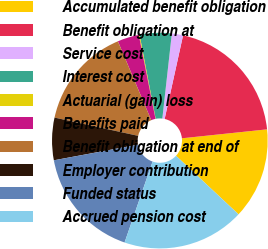Convert chart to OTSL. <chart><loc_0><loc_0><loc_500><loc_500><pie_chart><fcel>Accumulated benefit obligation<fcel>Benefit obligation at<fcel>Service cost<fcel>Interest cost<fcel>Actuarial (gain) loss<fcel>Benefits paid<fcel>Benefit obligation at end of<fcel>Employer contribution<fcel>Funded status<fcel>Accrued pension cost<nl><fcel>13.65%<fcel>19.88%<fcel>1.68%<fcel>4.79%<fcel>0.12%<fcel>3.23%<fcel>15.21%<fcel>6.35%<fcel>16.77%<fcel>18.32%<nl></chart> 